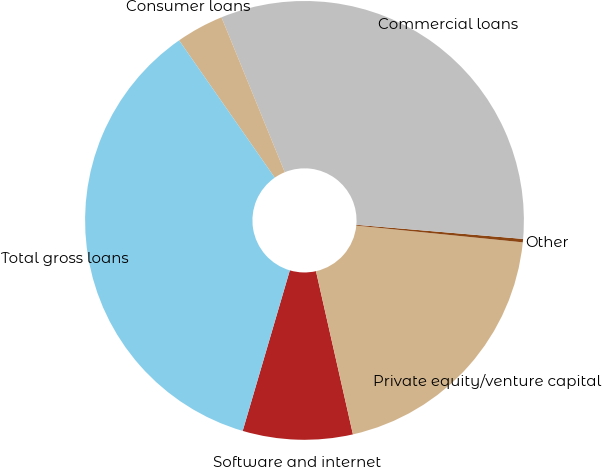<chart> <loc_0><loc_0><loc_500><loc_500><pie_chart><fcel>Software and internet<fcel>Private equity/venture capital<fcel>Other<fcel>Commercial loans<fcel>Consumer loans<fcel>Total gross loans<nl><fcel>8.09%<fcel>19.86%<fcel>0.25%<fcel>32.52%<fcel>3.51%<fcel>35.77%<nl></chart> 